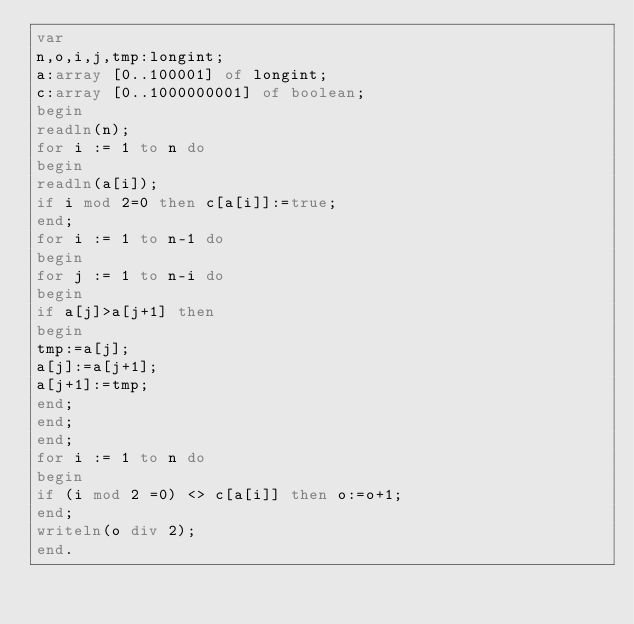Convert code to text. <code><loc_0><loc_0><loc_500><loc_500><_Pascal_>var
n,o,i,j,tmp:longint;
a:array [0..100001] of longint;
c:array [0..1000000001] of boolean;
begin
readln(n);
for i := 1 to n do
begin
readln(a[i]);
if i mod 2=0 then c[a[i]]:=true;
end;
for i := 1 to n-1 do
begin
for j := 1 to n-i do
begin
if a[j]>a[j+1] then
begin
tmp:=a[j];
a[j]:=a[j+1];
a[j+1]:=tmp;
end;
end;
end;
for i := 1 to n do
begin
if (i mod 2 =0) <> c[a[i]] then o:=o+1;
end;
writeln(o div 2);
end.
</code> 